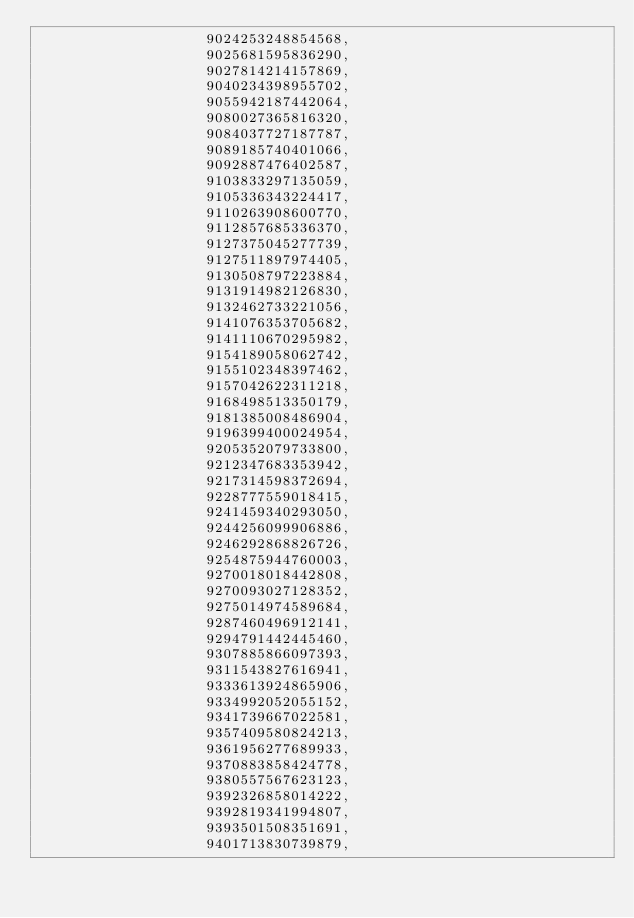Convert code to text. <code><loc_0><loc_0><loc_500><loc_500><_SML_>                    9024253248854568,
                    9025681595836290,
                    9027814214157869,
                    9040234398955702,
                    9055942187442064,
                    9080027365816320,
                    9084037727187787,
                    9089185740401066,
                    9092887476402587,
                    9103833297135059,
                    9105336343224417,
                    9110263908600770,
                    9112857685336370,
                    9127375045277739,
                    9127511897974405,
                    9130508797223884,
                    9131914982126830,
                    9132462733221056,
                    9141076353705682,
                    9141110670295982,
                    9154189058062742,
                    9155102348397462,
                    9157042622311218,
                    9168498513350179,
                    9181385008486904,
                    9196399400024954,
                    9205352079733800,
                    9212347683353942,
                    9217314598372694,
                    9228777559018415,
                    9241459340293050,
                    9244256099906886,
                    9246292868826726,
                    9254875944760003,
                    9270018018442808,
                    9270093027128352,
                    9275014974589684,
                    9287460496912141,
                    9294791442445460,
                    9307885866097393,
                    9311543827616941,
                    9333613924865906,
                    9334992052055152,
                    9341739667022581,
                    9357409580824213,
                    9361956277689933,
                    9370883858424778,
                    9380557567623123,
                    9392326858014222,
                    9392819341994807,
                    9393501508351691,
                    9401713830739879,</code> 